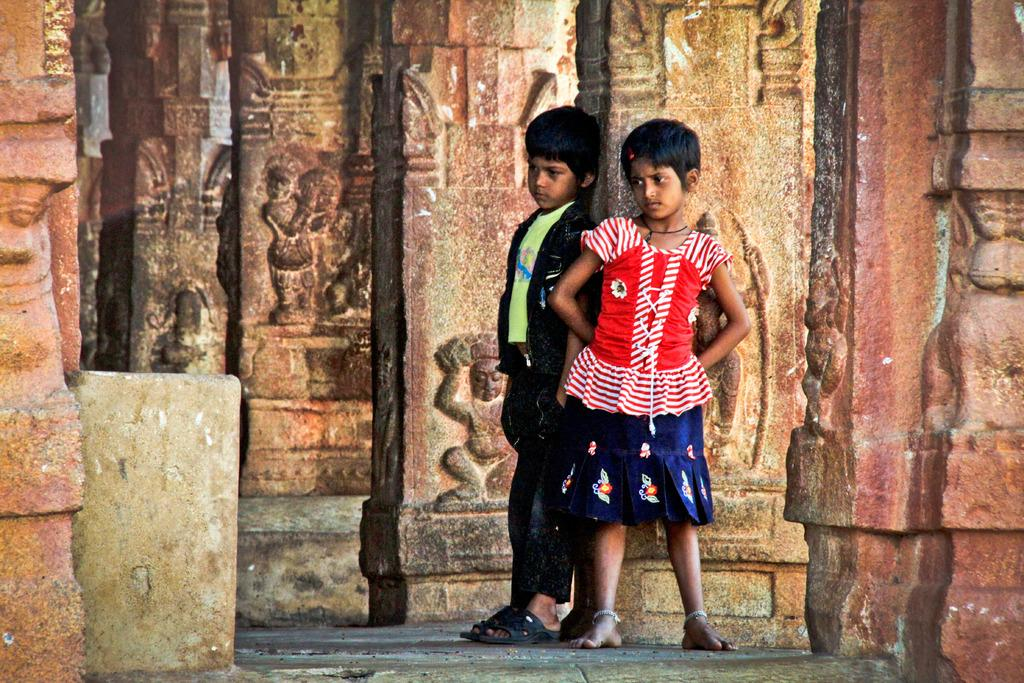How many children are in the image? There are two children in the image. Can you describe the clothing of the girl in the image? The girl is wearing a red dress. How is the boy dressed in the image? The boy is wearing a green T-shirt and blue jeans. What type of lace can be seen on the boy's shoes in the image? There is no mention of shoes or lace in the image, so it cannot be determined if any lace is present. 